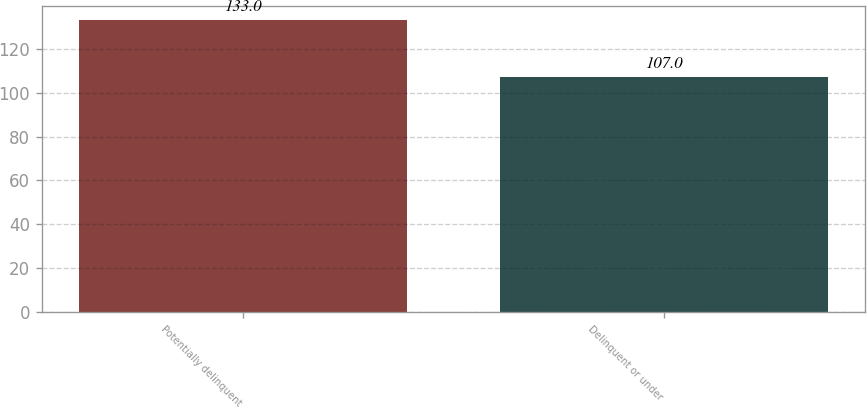Convert chart to OTSL. <chart><loc_0><loc_0><loc_500><loc_500><bar_chart><fcel>Potentially delinquent<fcel>Delinquent or under<nl><fcel>133<fcel>107<nl></chart> 